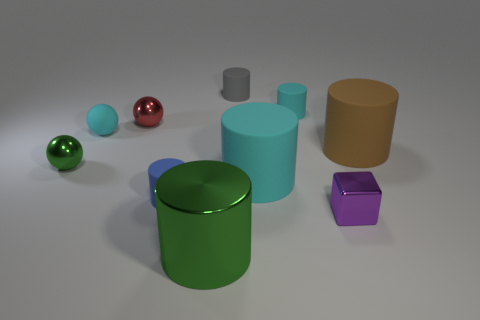Subtract 3 cylinders. How many cylinders are left? 3 Subtract all cyan cylinders. How many cylinders are left? 4 Subtract all tiny cyan matte cylinders. How many cylinders are left? 5 Subtract all red cylinders. Subtract all green spheres. How many cylinders are left? 6 Subtract all balls. How many objects are left? 7 Subtract all large yellow matte objects. Subtract all tiny blue rubber things. How many objects are left? 9 Add 1 small blue cylinders. How many small blue cylinders are left? 2 Add 10 blue metal cylinders. How many blue metal cylinders exist? 10 Subtract 0 brown balls. How many objects are left? 10 